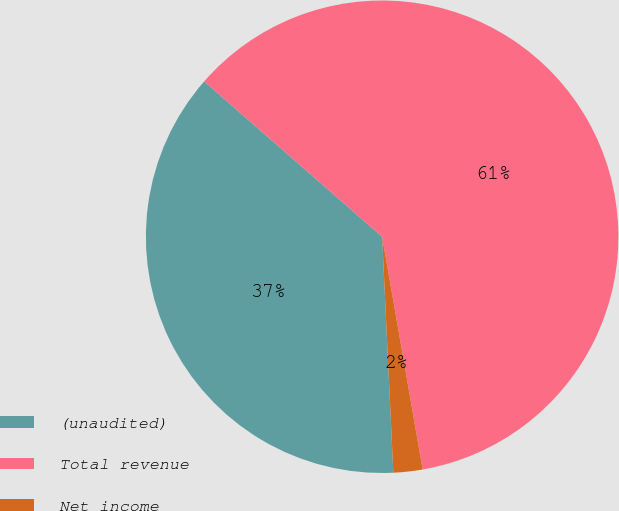Convert chart to OTSL. <chart><loc_0><loc_0><loc_500><loc_500><pie_chart><fcel>(unaudited)<fcel>Total revenue<fcel>Net income<nl><fcel>37.18%<fcel>60.84%<fcel>1.99%<nl></chart> 